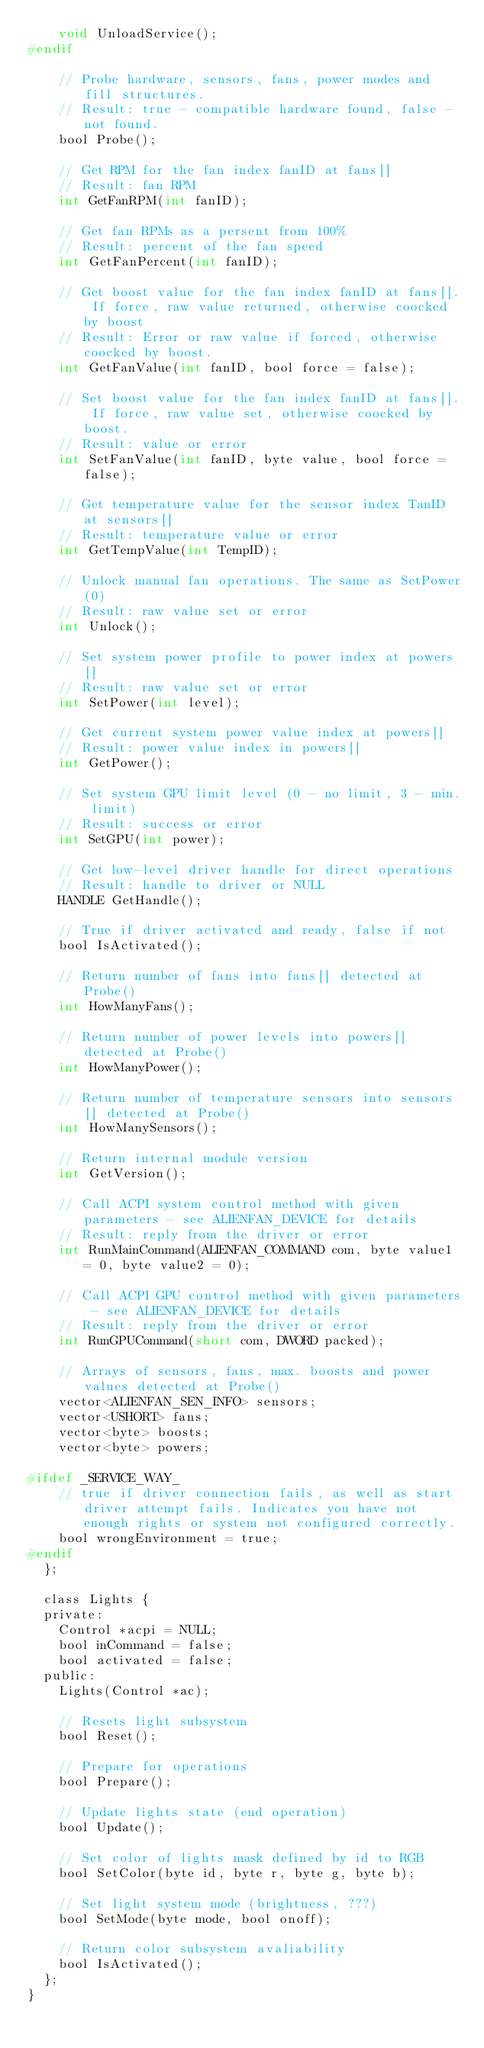Convert code to text. <code><loc_0><loc_0><loc_500><loc_500><_C_>		void UnloadService();
#endif

		// Probe hardware, sensors, fans, power modes and fill structures.
		// Result: true - compatible hardware found, false - not found.
		bool Probe();

		// Get RPM for the fan index fanID at fans[]
		// Result: fan RPM
		int GetFanRPM(int fanID);

		// Get fan RPMs as a persent from 100%
		// Result: percent of the fan speed
		int GetFanPercent(int fanID);

		// Get boost value for the fan index fanID at fans[]. If force, raw value returned, otherwise coocked by boost
		// Result: Error or raw value if forced, otherwise coocked by boost.
		int GetFanValue(int fanID, bool force = false);

		// Set boost value for the fan index fanID at fans[]. If force, raw value set, otherwise coocked by boost.
		// Result: value or error
		int SetFanValue(int fanID, byte value, bool force = false);

		// Get temperature value for the sensor index TanID at sensors[]
		// Result: temperature value or error
		int GetTempValue(int TempID);

		// Unlock manual fan operations. The same as SetPower(0)
		// Result: raw value set or error
		int Unlock();

		// Set system power profile to power index at powers[]
		// Result: raw value set or error
		int SetPower(int level);

		// Get current system power value index at powers[]
		// Result: power value index in powers[]
		int GetPower();

		// Set system GPU limit level (0 - no limit, 3 - min. limit)
		// Result: success or error
		int SetGPU(int power);

		// Get low-level driver handle for direct operations
		// Result: handle to driver or NULL
		HANDLE GetHandle();

		// True if driver activated and ready, false if not
		bool IsActivated();

		// Return number of fans into fans[] detected at Probe()
		int HowManyFans();

		// Return number of power levels into powers[] detected at Probe()
		int HowManyPower();

		// Return number of temperature sensors into sensors[] detected at Probe()
		int HowManySensors();

		// Return internal module version
		int GetVersion();

		// Call ACPI system control method with given parameters - see ALIENFAN_DEVICE for details
		// Result: reply from the driver or error
		int RunMainCommand(ALIENFAN_COMMAND com, byte value1 = 0, byte value2 = 0);

		// Call ACPI GPU control method with given parameters - see ALIENFAN_DEVICE for details
		// Result: reply from the driver or error
		int RunGPUCommand(short com, DWORD packed);

		// Arrays of sensors, fans, max. boosts and power values detected at Probe()
		vector<ALIENFAN_SEN_INFO> sensors;
		vector<USHORT> fans;
		vector<byte> boosts;
		vector<byte> powers;

#ifdef _SERVICE_WAY_
		// true if driver connection fails, as well as start driver attempt fails. Indicates you have not enough rights or system not configured correctly.
		bool wrongEnvironment = true;
#endif
	};

	class Lights {
	private:
		Control *acpi = NULL;
		bool inCommand = false;
		bool activated = false;
	public:
		Lights(Control *ac);

		// Resets light subsystem
		bool Reset();

		// Prepare for operations
		bool Prepare();

		// Update lights state (end operation)
		bool Update();

		// Set color of lights mask defined by id to RGB
		bool SetColor(byte id, byte r, byte g, byte b);

		// Set light system mode (brightness, ???)
		bool SetMode(byte mode, bool onoff);

		// Return color subsystem avaliability
		bool IsActivated();
	};
}
</code> 